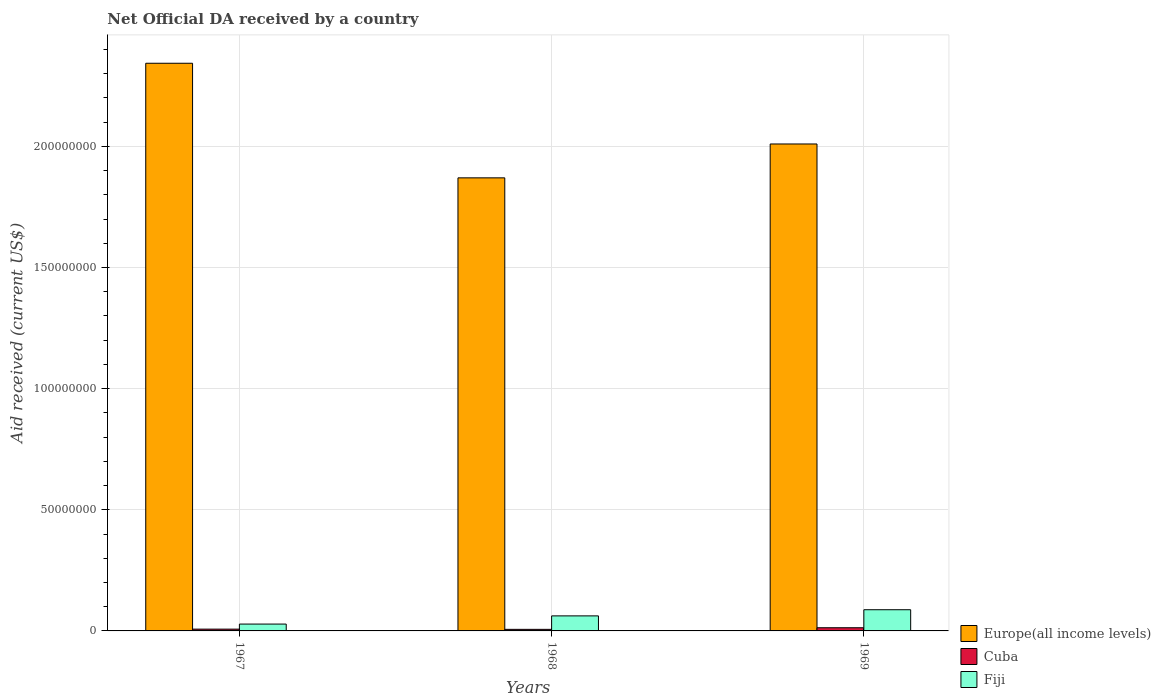How many groups of bars are there?
Your response must be concise. 3. How many bars are there on the 3rd tick from the left?
Your response must be concise. 3. How many bars are there on the 1st tick from the right?
Give a very brief answer. 3. What is the label of the 2nd group of bars from the left?
Keep it short and to the point. 1968. In how many cases, is the number of bars for a given year not equal to the number of legend labels?
Provide a short and direct response. 0. What is the net official development assistance aid received in Cuba in 1968?
Your response must be concise. 6.50e+05. Across all years, what is the maximum net official development assistance aid received in Europe(all income levels)?
Offer a very short reply. 2.34e+08. Across all years, what is the minimum net official development assistance aid received in Europe(all income levels)?
Your answer should be very brief. 1.87e+08. In which year was the net official development assistance aid received in Cuba maximum?
Your answer should be very brief. 1969. In which year was the net official development assistance aid received in Cuba minimum?
Make the answer very short. 1968. What is the total net official development assistance aid received in Europe(all income levels) in the graph?
Provide a succinct answer. 6.22e+08. What is the difference between the net official development assistance aid received in Cuba in 1967 and that in 1968?
Your response must be concise. 9.00e+04. What is the difference between the net official development assistance aid received in Europe(all income levels) in 1968 and the net official development assistance aid received in Fiji in 1969?
Offer a very short reply. 1.78e+08. What is the average net official development assistance aid received in Fiji per year?
Give a very brief answer. 5.93e+06. In the year 1969, what is the difference between the net official development assistance aid received in Fiji and net official development assistance aid received in Cuba?
Offer a very short reply. 7.44e+06. In how many years, is the net official development assistance aid received in Europe(all income levels) greater than 50000000 US$?
Make the answer very short. 3. What is the ratio of the net official development assistance aid received in Cuba in 1967 to that in 1968?
Provide a short and direct response. 1.14. Is the net official development assistance aid received in Cuba in 1968 less than that in 1969?
Your answer should be very brief. Yes. What is the difference between the highest and the second highest net official development assistance aid received in Fiji?
Give a very brief answer. 2.54e+06. What is the difference between the highest and the lowest net official development assistance aid received in Cuba?
Provide a short and direct response. 6.60e+05. Is the sum of the net official development assistance aid received in Fiji in 1968 and 1969 greater than the maximum net official development assistance aid received in Europe(all income levels) across all years?
Offer a terse response. No. What does the 3rd bar from the left in 1968 represents?
Offer a terse response. Fiji. What does the 1st bar from the right in 1967 represents?
Your response must be concise. Fiji. How many bars are there?
Your answer should be compact. 9. Are all the bars in the graph horizontal?
Keep it short and to the point. No. How many years are there in the graph?
Provide a succinct answer. 3. What is the difference between two consecutive major ticks on the Y-axis?
Offer a very short reply. 5.00e+07. Are the values on the major ticks of Y-axis written in scientific E-notation?
Ensure brevity in your answer.  No. Does the graph contain grids?
Offer a very short reply. Yes. How many legend labels are there?
Offer a terse response. 3. How are the legend labels stacked?
Ensure brevity in your answer.  Vertical. What is the title of the graph?
Your response must be concise. Net Official DA received by a country. Does "Armenia" appear as one of the legend labels in the graph?
Provide a short and direct response. No. What is the label or title of the Y-axis?
Your answer should be very brief. Aid received (current US$). What is the Aid received (current US$) in Europe(all income levels) in 1967?
Your response must be concise. 2.34e+08. What is the Aid received (current US$) of Cuba in 1967?
Provide a succinct answer. 7.40e+05. What is the Aid received (current US$) in Fiji in 1967?
Offer a terse response. 2.83e+06. What is the Aid received (current US$) of Europe(all income levels) in 1968?
Keep it short and to the point. 1.87e+08. What is the Aid received (current US$) of Cuba in 1968?
Make the answer very short. 6.50e+05. What is the Aid received (current US$) of Fiji in 1968?
Your response must be concise. 6.21e+06. What is the Aid received (current US$) in Europe(all income levels) in 1969?
Provide a short and direct response. 2.01e+08. What is the Aid received (current US$) of Cuba in 1969?
Ensure brevity in your answer.  1.31e+06. What is the Aid received (current US$) in Fiji in 1969?
Your response must be concise. 8.75e+06. Across all years, what is the maximum Aid received (current US$) in Europe(all income levels)?
Ensure brevity in your answer.  2.34e+08. Across all years, what is the maximum Aid received (current US$) in Cuba?
Ensure brevity in your answer.  1.31e+06. Across all years, what is the maximum Aid received (current US$) of Fiji?
Keep it short and to the point. 8.75e+06. Across all years, what is the minimum Aid received (current US$) of Europe(all income levels)?
Your answer should be compact. 1.87e+08. Across all years, what is the minimum Aid received (current US$) in Cuba?
Offer a very short reply. 6.50e+05. Across all years, what is the minimum Aid received (current US$) in Fiji?
Keep it short and to the point. 2.83e+06. What is the total Aid received (current US$) in Europe(all income levels) in the graph?
Offer a very short reply. 6.22e+08. What is the total Aid received (current US$) of Cuba in the graph?
Make the answer very short. 2.70e+06. What is the total Aid received (current US$) in Fiji in the graph?
Provide a short and direct response. 1.78e+07. What is the difference between the Aid received (current US$) of Europe(all income levels) in 1967 and that in 1968?
Give a very brief answer. 4.73e+07. What is the difference between the Aid received (current US$) in Cuba in 1967 and that in 1968?
Your answer should be compact. 9.00e+04. What is the difference between the Aid received (current US$) in Fiji in 1967 and that in 1968?
Make the answer very short. -3.38e+06. What is the difference between the Aid received (current US$) of Europe(all income levels) in 1967 and that in 1969?
Provide a succinct answer. 3.33e+07. What is the difference between the Aid received (current US$) of Cuba in 1967 and that in 1969?
Your answer should be compact. -5.70e+05. What is the difference between the Aid received (current US$) of Fiji in 1967 and that in 1969?
Offer a terse response. -5.92e+06. What is the difference between the Aid received (current US$) of Europe(all income levels) in 1968 and that in 1969?
Keep it short and to the point. -1.40e+07. What is the difference between the Aid received (current US$) of Cuba in 1968 and that in 1969?
Your answer should be compact. -6.60e+05. What is the difference between the Aid received (current US$) of Fiji in 1968 and that in 1969?
Provide a short and direct response. -2.54e+06. What is the difference between the Aid received (current US$) in Europe(all income levels) in 1967 and the Aid received (current US$) in Cuba in 1968?
Your answer should be very brief. 2.34e+08. What is the difference between the Aid received (current US$) in Europe(all income levels) in 1967 and the Aid received (current US$) in Fiji in 1968?
Provide a succinct answer. 2.28e+08. What is the difference between the Aid received (current US$) in Cuba in 1967 and the Aid received (current US$) in Fiji in 1968?
Your answer should be compact. -5.47e+06. What is the difference between the Aid received (current US$) in Europe(all income levels) in 1967 and the Aid received (current US$) in Cuba in 1969?
Give a very brief answer. 2.33e+08. What is the difference between the Aid received (current US$) in Europe(all income levels) in 1967 and the Aid received (current US$) in Fiji in 1969?
Your answer should be compact. 2.26e+08. What is the difference between the Aid received (current US$) in Cuba in 1967 and the Aid received (current US$) in Fiji in 1969?
Provide a short and direct response. -8.01e+06. What is the difference between the Aid received (current US$) of Europe(all income levels) in 1968 and the Aid received (current US$) of Cuba in 1969?
Your response must be concise. 1.86e+08. What is the difference between the Aid received (current US$) of Europe(all income levels) in 1968 and the Aid received (current US$) of Fiji in 1969?
Keep it short and to the point. 1.78e+08. What is the difference between the Aid received (current US$) in Cuba in 1968 and the Aid received (current US$) in Fiji in 1969?
Your response must be concise. -8.10e+06. What is the average Aid received (current US$) of Europe(all income levels) per year?
Your answer should be compact. 2.07e+08. What is the average Aid received (current US$) of Cuba per year?
Your response must be concise. 9.00e+05. What is the average Aid received (current US$) of Fiji per year?
Provide a succinct answer. 5.93e+06. In the year 1967, what is the difference between the Aid received (current US$) of Europe(all income levels) and Aid received (current US$) of Cuba?
Provide a short and direct response. 2.34e+08. In the year 1967, what is the difference between the Aid received (current US$) of Europe(all income levels) and Aid received (current US$) of Fiji?
Keep it short and to the point. 2.31e+08. In the year 1967, what is the difference between the Aid received (current US$) in Cuba and Aid received (current US$) in Fiji?
Offer a terse response. -2.09e+06. In the year 1968, what is the difference between the Aid received (current US$) in Europe(all income levels) and Aid received (current US$) in Cuba?
Provide a succinct answer. 1.86e+08. In the year 1968, what is the difference between the Aid received (current US$) in Europe(all income levels) and Aid received (current US$) in Fiji?
Provide a short and direct response. 1.81e+08. In the year 1968, what is the difference between the Aid received (current US$) in Cuba and Aid received (current US$) in Fiji?
Offer a very short reply. -5.56e+06. In the year 1969, what is the difference between the Aid received (current US$) of Europe(all income levels) and Aid received (current US$) of Cuba?
Offer a very short reply. 2.00e+08. In the year 1969, what is the difference between the Aid received (current US$) of Europe(all income levels) and Aid received (current US$) of Fiji?
Offer a very short reply. 1.92e+08. In the year 1969, what is the difference between the Aid received (current US$) of Cuba and Aid received (current US$) of Fiji?
Your answer should be very brief. -7.44e+06. What is the ratio of the Aid received (current US$) in Europe(all income levels) in 1967 to that in 1968?
Ensure brevity in your answer.  1.25. What is the ratio of the Aid received (current US$) in Cuba in 1967 to that in 1968?
Provide a succinct answer. 1.14. What is the ratio of the Aid received (current US$) in Fiji in 1967 to that in 1968?
Offer a terse response. 0.46. What is the ratio of the Aid received (current US$) of Europe(all income levels) in 1967 to that in 1969?
Provide a succinct answer. 1.17. What is the ratio of the Aid received (current US$) in Cuba in 1967 to that in 1969?
Give a very brief answer. 0.56. What is the ratio of the Aid received (current US$) of Fiji in 1967 to that in 1969?
Keep it short and to the point. 0.32. What is the ratio of the Aid received (current US$) in Europe(all income levels) in 1968 to that in 1969?
Your answer should be compact. 0.93. What is the ratio of the Aid received (current US$) in Cuba in 1968 to that in 1969?
Give a very brief answer. 0.5. What is the ratio of the Aid received (current US$) of Fiji in 1968 to that in 1969?
Your response must be concise. 0.71. What is the difference between the highest and the second highest Aid received (current US$) in Europe(all income levels)?
Provide a short and direct response. 3.33e+07. What is the difference between the highest and the second highest Aid received (current US$) in Cuba?
Make the answer very short. 5.70e+05. What is the difference between the highest and the second highest Aid received (current US$) of Fiji?
Offer a terse response. 2.54e+06. What is the difference between the highest and the lowest Aid received (current US$) in Europe(all income levels)?
Ensure brevity in your answer.  4.73e+07. What is the difference between the highest and the lowest Aid received (current US$) of Fiji?
Keep it short and to the point. 5.92e+06. 